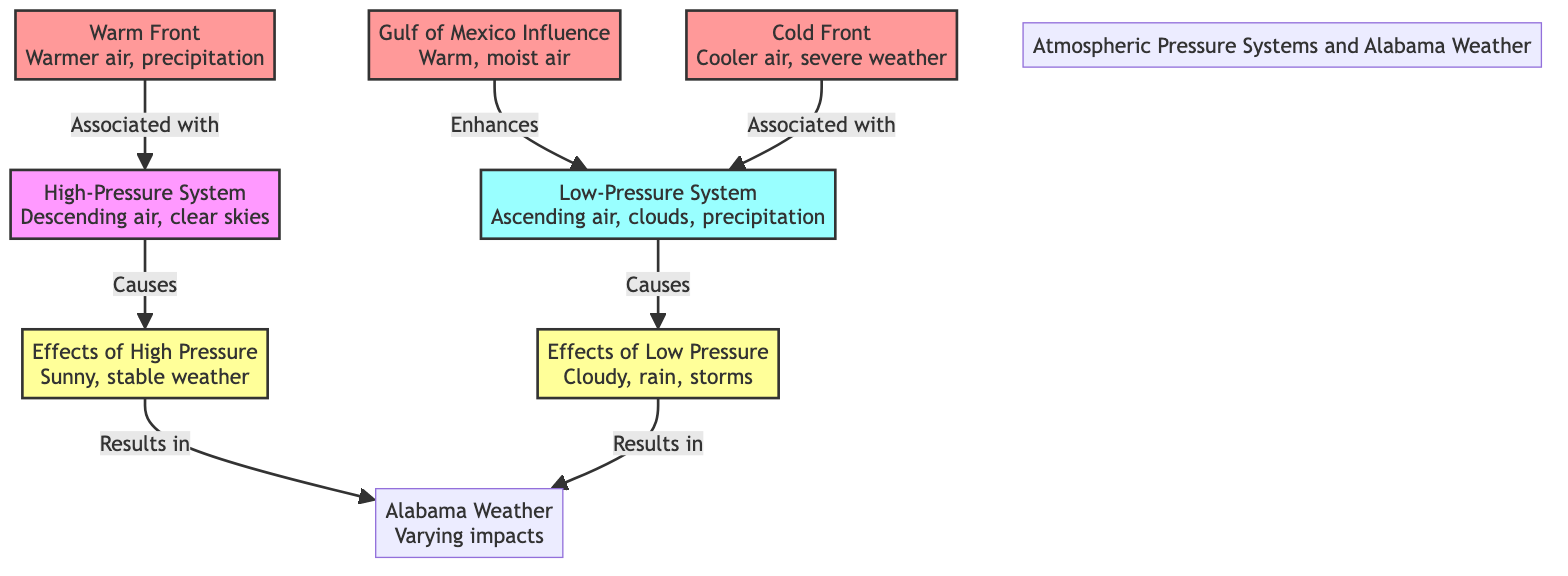What is the main characteristic of a high-pressure system? The diagram states that a high-pressure system is characterized by descending air and clear skies. This is a direct relationship shown in the diagram where the node for the high-pressure system points to its effects.
Answer: Descending air, clear skies How many effects of low pressure are listed in the diagram? The diagram provides one node that outlines the effects of low pressure, indicating that there is a single clear effect mentioned.
Answer: One What influences the low-pressure system as indicated in the diagram? According to the connections in the diagram, the Gulf of Mexico influence enhances the low-pressure system and is specifically mentioned as related to it. This is indicated by the arrow connection pointing towards the low-pressure system.
Answer: Gulf of Mexico Influence What is the resulting weather effect of a low-pressure system? The diagram specifies that the effects of low pressure result in cloudy weather, rain, and storms. The arrow indicates this specific outcome from the low-pressure node to its effects.
Answer: Cloudy, rain, storms Which front is associated with warmer air and precipitation? In the diagram, the warm front is clearly labeled as being associated with warmer air and precipitation. The connection is shown between the warm front and the high-pressure system.
Answer: Warm Front Explain how a cold front influences the weather pattern in the diagram. The cold front is associated with the low-pressure system, which means it contributes to the conditions that lead to storms. This relationship is shown by an arrow leading from the cold front to the low-pressure node, indicating that it plays a role in enhancing low-pressure systems.
Answer: It contributes to low pressure How does high pressure result in Alabama weather? The flow in the diagram shows that the effects of high pressure lead to sunny and stable weather, which in turn influences the general weather pattern in Alabama. The relationships clearly connected by arrows illustrate how the high-pressure effects flow into Alabama weather results.
Answer: Sunny, stable weather What are the two types of pressure systems represented in the diagram? The diagram explicitly represents two types of pressure systems: high-pressure system and low-pressure system. Each is depicted as a distinct node in the flowchart.
Answer: High-Pressure System, Low-Pressure System What color represents the influence of the Gulf of Mexico on the diagram? The Gulf of Mexico Influence is represented in a distinct color (pinkish) in the diagram, which corresponds with a specific class defined for influences. By identifying the unique color and class shown, one can determine its representation.
Answer: Pinkish color 